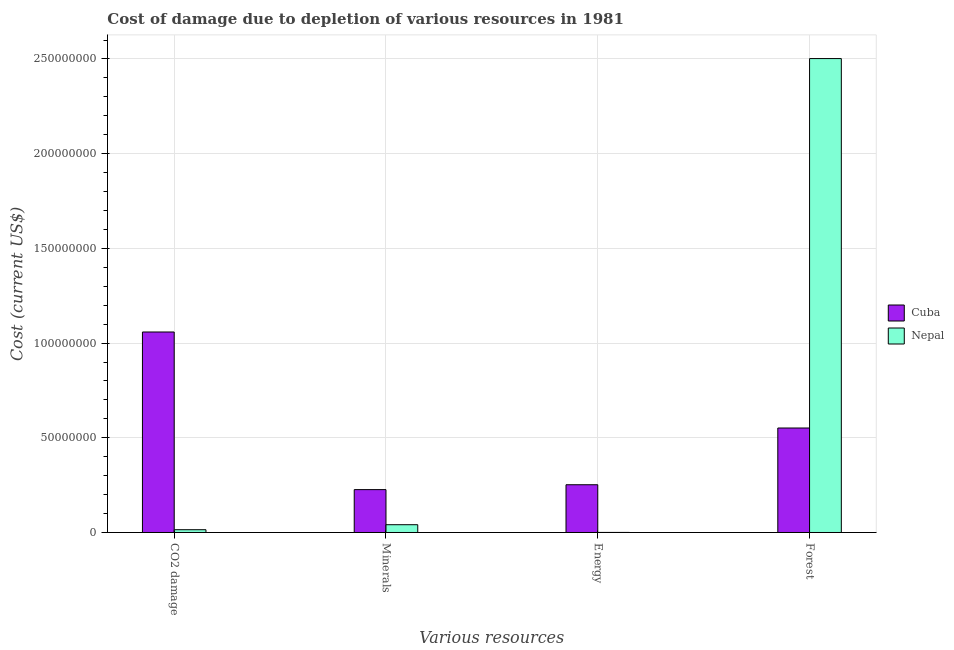How many groups of bars are there?
Your answer should be very brief. 4. Are the number of bars per tick equal to the number of legend labels?
Make the answer very short. Yes. Are the number of bars on each tick of the X-axis equal?
Offer a terse response. Yes. How many bars are there on the 4th tick from the right?
Make the answer very short. 2. What is the label of the 2nd group of bars from the left?
Offer a very short reply. Minerals. What is the cost of damage due to depletion of energy in Nepal?
Your response must be concise. 2.94e+04. Across all countries, what is the maximum cost of damage due to depletion of forests?
Your answer should be very brief. 2.50e+08. Across all countries, what is the minimum cost of damage due to depletion of forests?
Provide a succinct answer. 5.52e+07. In which country was the cost of damage due to depletion of energy maximum?
Give a very brief answer. Cuba. In which country was the cost of damage due to depletion of energy minimum?
Provide a succinct answer. Nepal. What is the total cost of damage due to depletion of coal in the graph?
Offer a very short reply. 1.07e+08. What is the difference between the cost of damage due to depletion of minerals in Cuba and that in Nepal?
Offer a very short reply. 1.85e+07. What is the difference between the cost of damage due to depletion of coal in Cuba and the cost of damage due to depletion of forests in Nepal?
Ensure brevity in your answer.  -1.44e+08. What is the average cost of damage due to depletion of minerals per country?
Offer a very short reply. 1.34e+07. What is the difference between the cost of damage due to depletion of coal and cost of damage due to depletion of minerals in Cuba?
Provide a succinct answer. 8.32e+07. In how many countries, is the cost of damage due to depletion of coal greater than 60000000 US$?
Ensure brevity in your answer.  1. What is the ratio of the cost of damage due to depletion of energy in Cuba to that in Nepal?
Ensure brevity in your answer.  858.65. Is the cost of damage due to depletion of energy in Nepal less than that in Cuba?
Your response must be concise. Yes. Is the difference between the cost of damage due to depletion of coal in Cuba and Nepal greater than the difference between the cost of damage due to depletion of minerals in Cuba and Nepal?
Offer a terse response. Yes. What is the difference between the highest and the second highest cost of damage due to depletion of minerals?
Provide a short and direct response. 1.85e+07. What is the difference between the highest and the lowest cost of damage due to depletion of forests?
Keep it short and to the point. 1.95e+08. In how many countries, is the cost of damage due to depletion of energy greater than the average cost of damage due to depletion of energy taken over all countries?
Provide a short and direct response. 1. Is the sum of the cost of damage due to depletion of energy in Nepal and Cuba greater than the maximum cost of damage due to depletion of forests across all countries?
Your answer should be very brief. No. Is it the case that in every country, the sum of the cost of damage due to depletion of coal and cost of damage due to depletion of energy is greater than the sum of cost of damage due to depletion of forests and cost of damage due to depletion of minerals?
Your answer should be compact. No. What does the 2nd bar from the left in Minerals represents?
Offer a terse response. Nepal. What does the 2nd bar from the right in CO2 damage represents?
Provide a short and direct response. Cuba. Is it the case that in every country, the sum of the cost of damage due to depletion of coal and cost of damage due to depletion of minerals is greater than the cost of damage due to depletion of energy?
Offer a very short reply. Yes. How many bars are there?
Provide a short and direct response. 8. Does the graph contain any zero values?
Give a very brief answer. No. Where does the legend appear in the graph?
Ensure brevity in your answer.  Center right. What is the title of the graph?
Offer a terse response. Cost of damage due to depletion of various resources in 1981 . Does "Germany" appear as one of the legend labels in the graph?
Provide a short and direct response. No. What is the label or title of the X-axis?
Offer a very short reply. Various resources. What is the label or title of the Y-axis?
Provide a short and direct response. Cost (current US$). What is the Cost (current US$) in Cuba in CO2 damage?
Ensure brevity in your answer.  1.06e+08. What is the Cost (current US$) in Nepal in CO2 damage?
Give a very brief answer. 1.47e+06. What is the Cost (current US$) in Cuba in Minerals?
Provide a succinct answer. 2.26e+07. What is the Cost (current US$) of Nepal in Minerals?
Give a very brief answer. 4.10e+06. What is the Cost (current US$) in Cuba in Energy?
Your answer should be very brief. 2.52e+07. What is the Cost (current US$) in Nepal in Energy?
Your answer should be compact. 2.94e+04. What is the Cost (current US$) in Cuba in Forest?
Make the answer very short. 5.52e+07. What is the Cost (current US$) in Nepal in Forest?
Make the answer very short. 2.50e+08. Across all Various resources, what is the maximum Cost (current US$) in Cuba?
Offer a terse response. 1.06e+08. Across all Various resources, what is the maximum Cost (current US$) of Nepal?
Keep it short and to the point. 2.50e+08. Across all Various resources, what is the minimum Cost (current US$) in Cuba?
Make the answer very short. 2.26e+07. Across all Various resources, what is the minimum Cost (current US$) of Nepal?
Make the answer very short. 2.94e+04. What is the total Cost (current US$) in Cuba in the graph?
Provide a short and direct response. 2.09e+08. What is the total Cost (current US$) in Nepal in the graph?
Offer a very short reply. 2.56e+08. What is the difference between the Cost (current US$) of Cuba in CO2 damage and that in Minerals?
Your response must be concise. 8.32e+07. What is the difference between the Cost (current US$) in Nepal in CO2 damage and that in Minerals?
Ensure brevity in your answer.  -2.63e+06. What is the difference between the Cost (current US$) in Cuba in CO2 damage and that in Energy?
Your answer should be compact. 8.06e+07. What is the difference between the Cost (current US$) in Nepal in CO2 damage and that in Energy?
Your answer should be compact. 1.44e+06. What is the difference between the Cost (current US$) of Cuba in CO2 damage and that in Forest?
Provide a succinct answer. 5.07e+07. What is the difference between the Cost (current US$) in Nepal in CO2 damage and that in Forest?
Keep it short and to the point. -2.49e+08. What is the difference between the Cost (current US$) of Cuba in Minerals and that in Energy?
Make the answer very short. -2.57e+06. What is the difference between the Cost (current US$) in Nepal in Minerals and that in Energy?
Your response must be concise. 4.07e+06. What is the difference between the Cost (current US$) of Cuba in Minerals and that in Forest?
Provide a short and direct response. -3.25e+07. What is the difference between the Cost (current US$) of Nepal in Minerals and that in Forest?
Your answer should be very brief. -2.46e+08. What is the difference between the Cost (current US$) of Cuba in Energy and that in Forest?
Keep it short and to the point. -3.00e+07. What is the difference between the Cost (current US$) of Nepal in Energy and that in Forest?
Offer a terse response. -2.50e+08. What is the difference between the Cost (current US$) of Cuba in CO2 damage and the Cost (current US$) of Nepal in Minerals?
Offer a very short reply. 1.02e+08. What is the difference between the Cost (current US$) in Cuba in CO2 damage and the Cost (current US$) in Nepal in Energy?
Provide a short and direct response. 1.06e+08. What is the difference between the Cost (current US$) of Cuba in CO2 damage and the Cost (current US$) of Nepal in Forest?
Your answer should be very brief. -1.44e+08. What is the difference between the Cost (current US$) in Cuba in Minerals and the Cost (current US$) in Nepal in Energy?
Offer a terse response. 2.26e+07. What is the difference between the Cost (current US$) in Cuba in Minerals and the Cost (current US$) in Nepal in Forest?
Your answer should be compact. -2.28e+08. What is the difference between the Cost (current US$) of Cuba in Energy and the Cost (current US$) of Nepal in Forest?
Your response must be concise. -2.25e+08. What is the average Cost (current US$) in Cuba per Various resources?
Your answer should be very brief. 5.22e+07. What is the average Cost (current US$) of Nepal per Various resources?
Ensure brevity in your answer.  6.40e+07. What is the difference between the Cost (current US$) in Cuba and Cost (current US$) in Nepal in CO2 damage?
Offer a terse response. 1.04e+08. What is the difference between the Cost (current US$) of Cuba and Cost (current US$) of Nepal in Minerals?
Provide a succinct answer. 1.85e+07. What is the difference between the Cost (current US$) of Cuba and Cost (current US$) of Nepal in Energy?
Provide a short and direct response. 2.52e+07. What is the difference between the Cost (current US$) of Cuba and Cost (current US$) of Nepal in Forest?
Ensure brevity in your answer.  -1.95e+08. What is the ratio of the Cost (current US$) of Cuba in CO2 damage to that in Minerals?
Give a very brief answer. 4.68. What is the ratio of the Cost (current US$) of Nepal in CO2 damage to that in Minerals?
Offer a terse response. 0.36. What is the ratio of the Cost (current US$) of Cuba in CO2 damage to that in Energy?
Your response must be concise. 4.2. What is the ratio of the Cost (current US$) in Nepal in CO2 damage to that in Energy?
Your response must be concise. 50.06. What is the ratio of the Cost (current US$) of Cuba in CO2 damage to that in Forest?
Your answer should be very brief. 1.92. What is the ratio of the Cost (current US$) of Nepal in CO2 damage to that in Forest?
Keep it short and to the point. 0.01. What is the ratio of the Cost (current US$) of Cuba in Minerals to that in Energy?
Ensure brevity in your answer.  0.9. What is the ratio of the Cost (current US$) in Nepal in Minerals to that in Energy?
Provide a succinct answer. 139.72. What is the ratio of the Cost (current US$) of Cuba in Minerals to that in Forest?
Offer a very short reply. 0.41. What is the ratio of the Cost (current US$) of Nepal in Minerals to that in Forest?
Your response must be concise. 0.02. What is the ratio of the Cost (current US$) of Cuba in Energy to that in Forest?
Your answer should be very brief. 0.46. What is the ratio of the Cost (current US$) in Nepal in Energy to that in Forest?
Make the answer very short. 0. What is the difference between the highest and the second highest Cost (current US$) in Cuba?
Offer a terse response. 5.07e+07. What is the difference between the highest and the second highest Cost (current US$) of Nepal?
Give a very brief answer. 2.46e+08. What is the difference between the highest and the lowest Cost (current US$) in Cuba?
Provide a succinct answer. 8.32e+07. What is the difference between the highest and the lowest Cost (current US$) in Nepal?
Offer a terse response. 2.50e+08. 